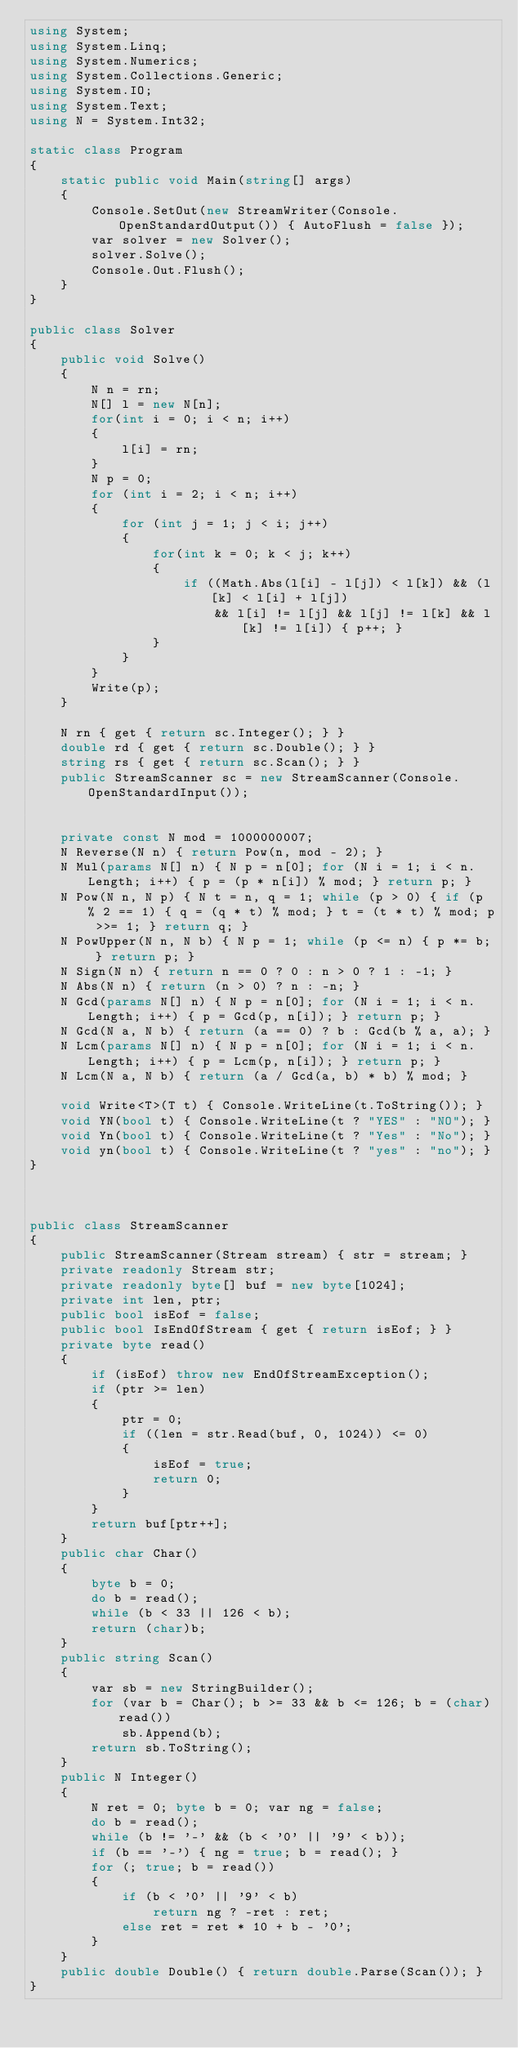<code> <loc_0><loc_0><loc_500><loc_500><_C#_>using System;
using System.Linq;
using System.Numerics;
using System.Collections.Generic;
using System.IO;
using System.Text;
using N = System.Int32;

static class Program
{
    static public void Main(string[] args)
    {
        Console.SetOut(new StreamWriter(Console.OpenStandardOutput()) { AutoFlush = false });
        var solver = new Solver();
        solver.Solve();
        Console.Out.Flush();
    }
}

public class Solver
{
    public void Solve()
    {
        N n = rn;
        N[] l = new N[n];
        for(int i = 0; i < n; i++)
        {
            l[i] = rn;
        }
        N p = 0;
        for (int i = 2; i < n; i++)
        {
            for (int j = 1; j < i; j++)
            {
                for(int k = 0; k < j; k++)
                {
                    if ((Math.Abs(l[i] - l[j]) < l[k]) && (l[k] < l[i] + l[j])
                        && l[i] != l[j] && l[j] != l[k] && l[k] != l[i]) { p++; }
                }
            }
        }
        Write(p);
    }

    N rn { get { return sc.Integer(); } }
    double rd { get { return sc.Double(); } }
    string rs { get { return sc.Scan(); } }
    public StreamScanner sc = new StreamScanner(Console.OpenStandardInput());


    private const N mod = 1000000007;
    N Reverse(N n) { return Pow(n, mod - 2); }
    N Mul(params N[] n) { N p = n[0]; for (N i = 1; i < n.Length; i++) { p = (p * n[i]) % mod; } return p; }
    N Pow(N n, N p) { N t = n, q = 1; while (p > 0) { if (p % 2 == 1) { q = (q * t) % mod; } t = (t * t) % mod; p >>= 1; } return q; }
    N PowUpper(N n, N b) { N p = 1; while (p <= n) { p *= b; } return p; }
    N Sign(N n) { return n == 0 ? 0 : n > 0 ? 1 : -1; }
    N Abs(N n) { return (n > 0) ? n : -n; }
    N Gcd(params N[] n) { N p = n[0]; for (N i = 1; i < n.Length; i++) { p = Gcd(p, n[i]); } return p; }
    N Gcd(N a, N b) { return (a == 0) ? b : Gcd(b % a, a); }
    N Lcm(params N[] n) { N p = n[0]; for (N i = 1; i < n.Length; i++) { p = Lcm(p, n[i]); } return p; }
    N Lcm(N a, N b) { return (a / Gcd(a, b) * b) % mod; }

    void Write<T>(T t) { Console.WriteLine(t.ToString()); }
    void YN(bool t) { Console.WriteLine(t ? "YES" : "NO"); }
    void Yn(bool t) { Console.WriteLine(t ? "Yes" : "No"); }
    void yn(bool t) { Console.WriteLine(t ? "yes" : "no"); }
}



public class StreamScanner
{
    public StreamScanner(Stream stream) { str = stream; }
    private readonly Stream str;
    private readonly byte[] buf = new byte[1024];
    private int len, ptr;
    public bool isEof = false;
    public bool IsEndOfStream { get { return isEof; } }
    private byte read()
    {
        if (isEof) throw new EndOfStreamException();
        if (ptr >= len)
        {
            ptr = 0;
            if ((len = str.Read(buf, 0, 1024)) <= 0)
            {
                isEof = true;
                return 0;
            }
        }
        return buf[ptr++];
    }
    public char Char()
    {
        byte b = 0;
        do b = read();
        while (b < 33 || 126 < b);
        return (char)b;
    }
    public string Scan()
    {
        var sb = new StringBuilder();
        for (var b = Char(); b >= 33 && b <= 126; b = (char)read())
            sb.Append(b);
        return sb.ToString();
    }
    public N Integer()
    {
        N ret = 0; byte b = 0; var ng = false;
        do b = read();
        while (b != '-' && (b < '0' || '9' < b));
        if (b == '-') { ng = true; b = read(); }
        for (; true; b = read())
        {
            if (b < '0' || '9' < b)
                return ng ? -ret : ret;
            else ret = ret * 10 + b - '0';
        }
    }
    public double Double() { return double.Parse(Scan()); }
}
</code> 